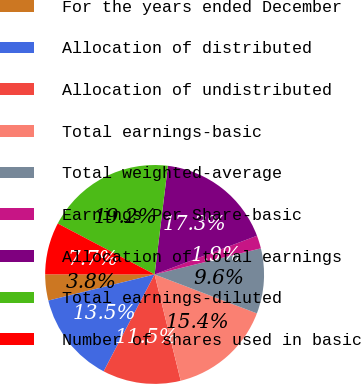Convert chart to OTSL. <chart><loc_0><loc_0><loc_500><loc_500><pie_chart><fcel>For the years ended December<fcel>Allocation of distributed<fcel>Allocation of undistributed<fcel>Total earnings-basic<fcel>Total weighted-average<fcel>Earnings Per Share-basic<fcel>Allocation of total earnings<fcel>Total earnings-diluted<fcel>Number of shares used in basic<nl><fcel>3.85%<fcel>13.46%<fcel>11.54%<fcel>15.38%<fcel>9.62%<fcel>1.92%<fcel>17.31%<fcel>19.23%<fcel>7.69%<nl></chart> 